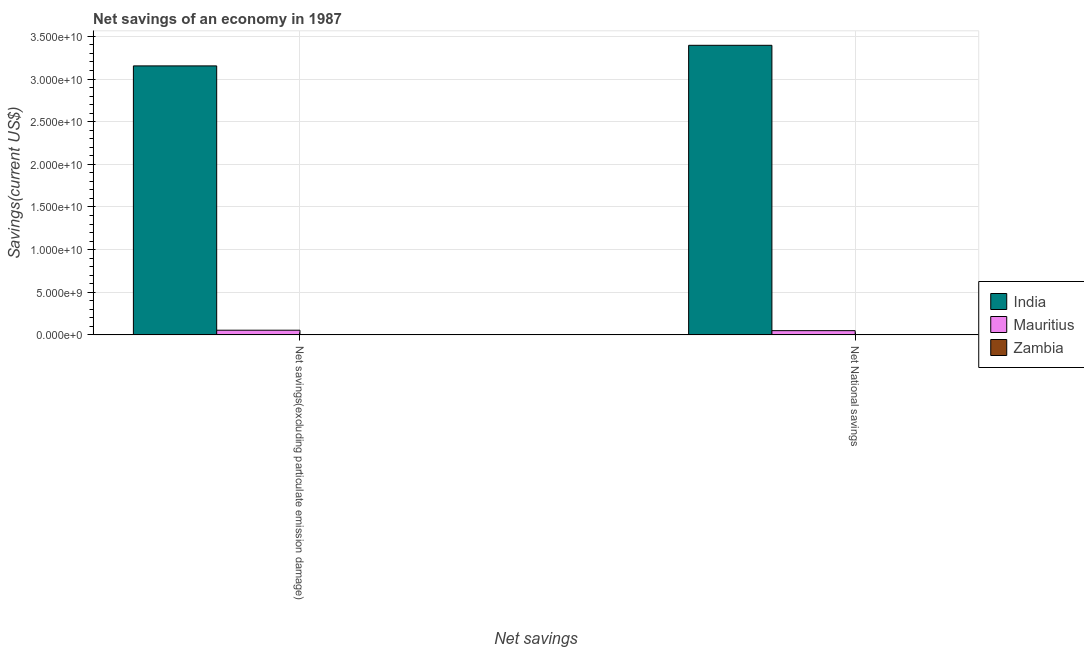How many different coloured bars are there?
Offer a terse response. 2. How many groups of bars are there?
Your answer should be very brief. 2. How many bars are there on the 1st tick from the left?
Your response must be concise. 2. How many bars are there on the 2nd tick from the right?
Offer a terse response. 2. What is the label of the 2nd group of bars from the left?
Offer a terse response. Net National savings. What is the net national savings in Mauritius?
Offer a very short reply. 4.98e+08. Across all countries, what is the maximum net national savings?
Ensure brevity in your answer.  3.40e+1. Across all countries, what is the minimum net national savings?
Your response must be concise. 0. What is the total net savings(excluding particulate emission damage) in the graph?
Ensure brevity in your answer.  3.21e+1. What is the difference between the net national savings in Mauritius and that in India?
Give a very brief answer. -3.35e+1. What is the difference between the net savings(excluding particulate emission damage) in Mauritius and the net national savings in Zambia?
Offer a very short reply. 5.49e+08. What is the average net national savings per country?
Provide a succinct answer. 1.15e+1. What is the difference between the net national savings and net savings(excluding particulate emission damage) in Mauritius?
Your answer should be compact. -5.05e+07. What is the ratio of the net savings(excluding particulate emission damage) in Mauritius to that in India?
Ensure brevity in your answer.  0.02. How many bars are there?
Your response must be concise. 4. How many countries are there in the graph?
Ensure brevity in your answer.  3. What is the difference between two consecutive major ticks on the Y-axis?
Your answer should be very brief. 5.00e+09. Are the values on the major ticks of Y-axis written in scientific E-notation?
Provide a short and direct response. Yes. Does the graph contain grids?
Offer a very short reply. Yes. Where does the legend appear in the graph?
Your answer should be compact. Center right. What is the title of the graph?
Give a very brief answer. Net savings of an economy in 1987. Does "Mauritania" appear as one of the legend labels in the graph?
Provide a succinct answer. No. What is the label or title of the X-axis?
Provide a short and direct response. Net savings. What is the label or title of the Y-axis?
Offer a terse response. Savings(current US$). What is the Savings(current US$) of India in Net savings(excluding particulate emission damage)?
Offer a terse response. 3.15e+1. What is the Savings(current US$) of Mauritius in Net savings(excluding particulate emission damage)?
Ensure brevity in your answer.  5.49e+08. What is the Savings(current US$) in Zambia in Net savings(excluding particulate emission damage)?
Your response must be concise. 0. What is the Savings(current US$) in India in Net National savings?
Give a very brief answer. 3.40e+1. What is the Savings(current US$) of Mauritius in Net National savings?
Your answer should be compact. 4.98e+08. Across all Net savings, what is the maximum Savings(current US$) of India?
Provide a succinct answer. 3.40e+1. Across all Net savings, what is the maximum Savings(current US$) in Mauritius?
Provide a succinct answer. 5.49e+08. Across all Net savings, what is the minimum Savings(current US$) of India?
Offer a terse response. 3.15e+1. Across all Net savings, what is the minimum Savings(current US$) of Mauritius?
Offer a terse response. 4.98e+08. What is the total Savings(current US$) of India in the graph?
Give a very brief answer. 6.55e+1. What is the total Savings(current US$) of Mauritius in the graph?
Your answer should be very brief. 1.05e+09. What is the difference between the Savings(current US$) of India in Net savings(excluding particulate emission damage) and that in Net National savings?
Offer a terse response. -2.41e+09. What is the difference between the Savings(current US$) in Mauritius in Net savings(excluding particulate emission damage) and that in Net National savings?
Provide a succinct answer. 5.05e+07. What is the difference between the Savings(current US$) of India in Net savings(excluding particulate emission damage) and the Savings(current US$) of Mauritius in Net National savings?
Provide a short and direct response. 3.10e+1. What is the average Savings(current US$) of India per Net savings?
Provide a succinct answer. 3.27e+1. What is the average Savings(current US$) of Mauritius per Net savings?
Keep it short and to the point. 5.23e+08. What is the average Savings(current US$) of Zambia per Net savings?
Offer a very short reply. 0. What is the difference between the Savings(current US$) in India and Savings(current US$) in Mauritius in Net savings(excluding particulate emission damage)?
Your answer should be compact. 3.10e+1. What is the difference between the Savings(current US$) in India and Savings(current US$) in Mauritius in Net National savings?
Provide a succinct answer. 3.35e+1. What is the ratio of the Savings(current US$) of India in Net savings(excluding particulate emission damage) to that in Net National savings?
Offer a very short reply. 0.93. What is the ratio of the Savings(current US$) in Mauritius in Net savings(excluding particulate emission damage) to that in Net National savings?
Your response must be concise. 1.1. What is the difference between the highest and the second highest Savings(current US$) in India?
Ensure brevity in your answer.  2.41e+09. What is the difference between the highest and the second highest Savings(current US$) of Mauritius?
Make the answer very short. 5.05e+07. What is the difference between the highest and the lowest Savings(current US$) in India?
Offer a terse response. 2.41e+09. What is the difference between the highest and the lowest Savings(current US$) in Mauritius?
Make the answer very short. 5.05e+07. 